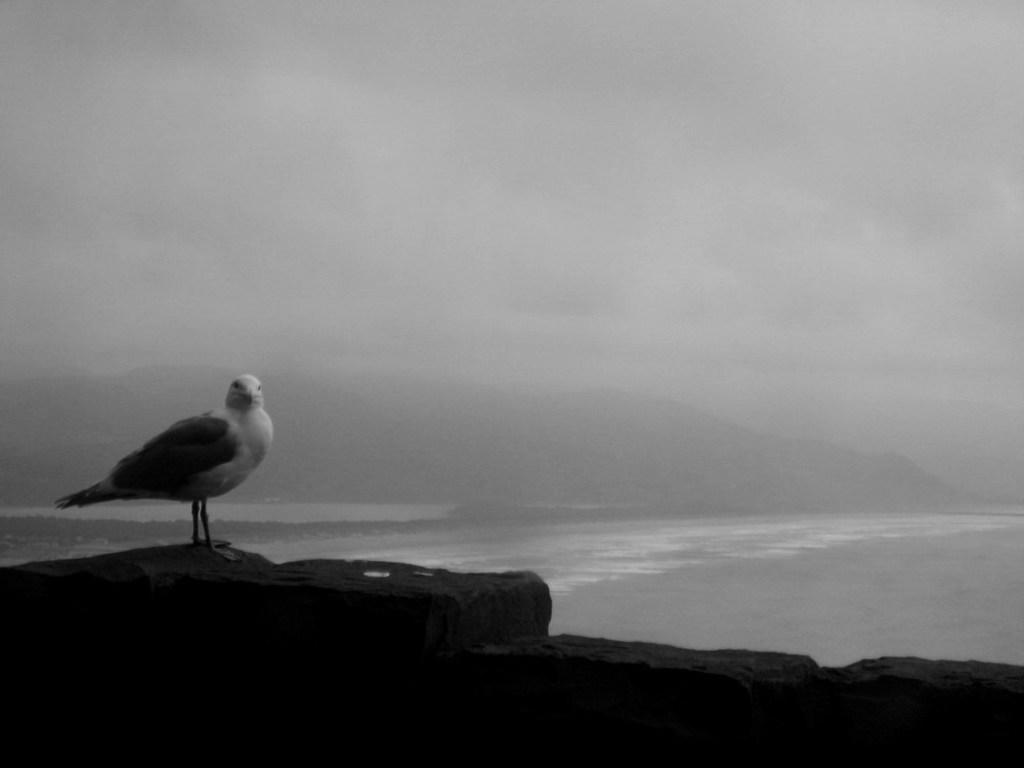Please provide a concise description of this image. Here we can see a bird. This is water. In the background there is sky. 